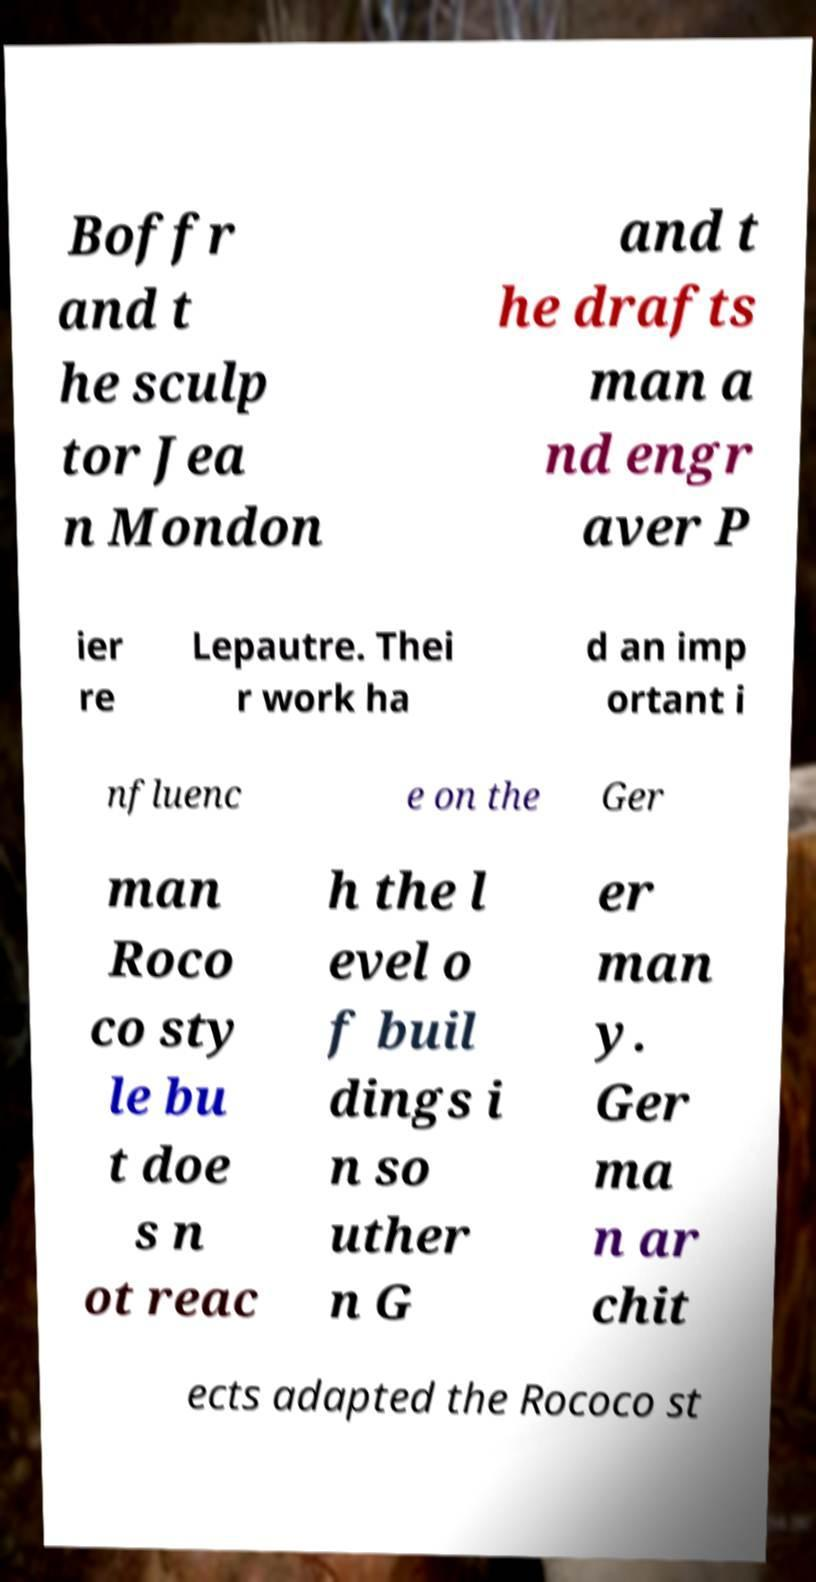Can you accurately transcribe the text from the provided image for me? Boffr and t he sculp tor Jea n Mondon and t he drafts man a nd engr aver P ier re Lepautre. Thei r work ha d an imp ortant i nfluenc e on the Ger man Roco co sty le bu t doe s n ot reac h the l evel o f buil dings i n so uther n G er man y. Ger ma n ar chit ects adapted the Rococo st 